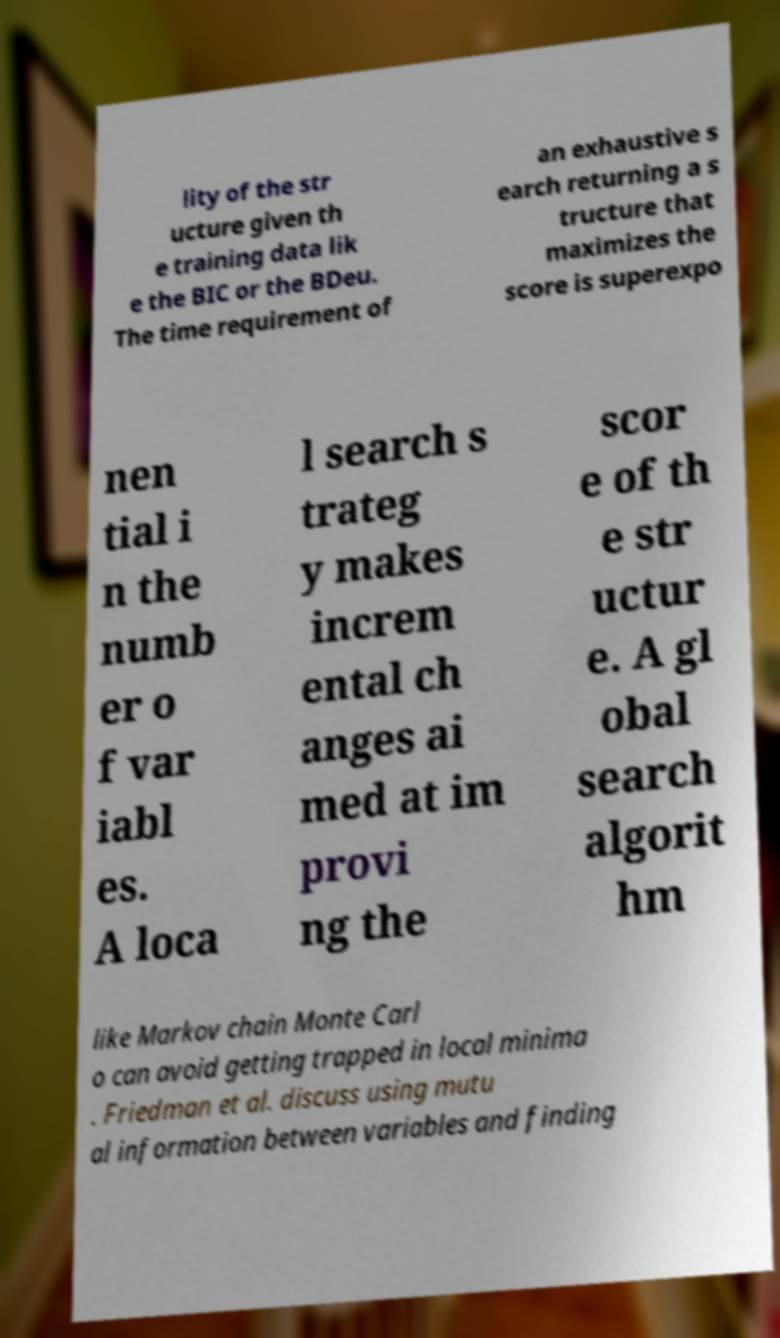Please identify and transcribe the text found in this image. lity of the str ucture given th e training data lik e the BIC or the BDeu. The time requirement of an exhaustive s earch returning a s tructure that maximizes the score is superexpo nen tial i n the numb er o f var iabl es. A loca l search s trateg y makes increm ental ch anges ai med at im provi ng the scor e of th e str uctur e. A gl obal search algorit hm like Markov chain Monte Carl o can avoid getting trapped in local minima . Friedman et al. discuss using mutu al information between variables and finding 